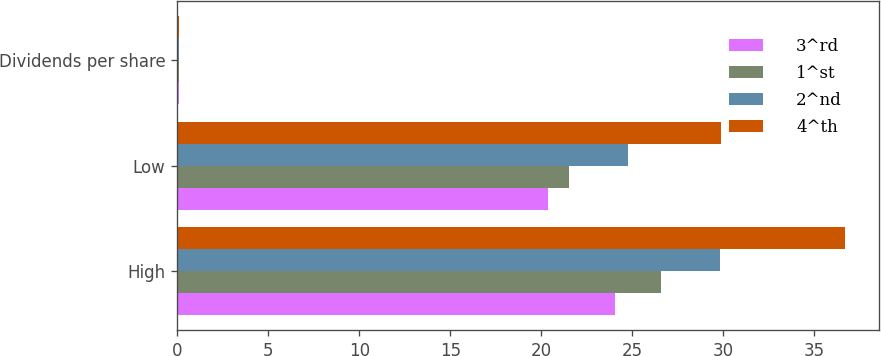<chart> <loc_0><loc_0><loc_500><loc_500><stacked_bar_chart><ecel><fcel>High<fcel>Low<fcel>Dividends per share<nl><fcel>3^rd<fcel>24.06<fcel>20.38<fcel>0.08<nl><fcel>1^st<fcel>26.6<fcel>21.54<fcel>0.08<nl><fcel>2^nd<fcel>29.79<fcel>24.77<fcel>0.1<nl><fcel>4^th<fcel>36.69<fcel>29.88<fcel>0.1<nl></chart> 